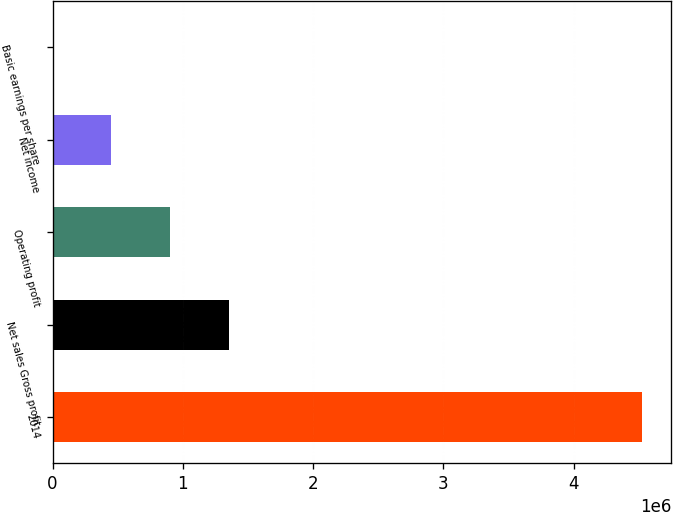Convert chart. <chart><loc_0><loc_0><loc_500><loc_500><bar_chart><fcel>2014<fcel>Net sales Gross profit<fcel>Operating profit<fcel>Net income<fcel>Basic earnings per share<nl><fcel>4.52208e+06<fcel>1.35775e+06<fcel>904417<fcel>452209<fcel>0.72<nl></chart> 